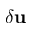Convert formula to latex. <formula><loc_0><loc_0><loc_500><loc_500>{ \delta u }</formula> 